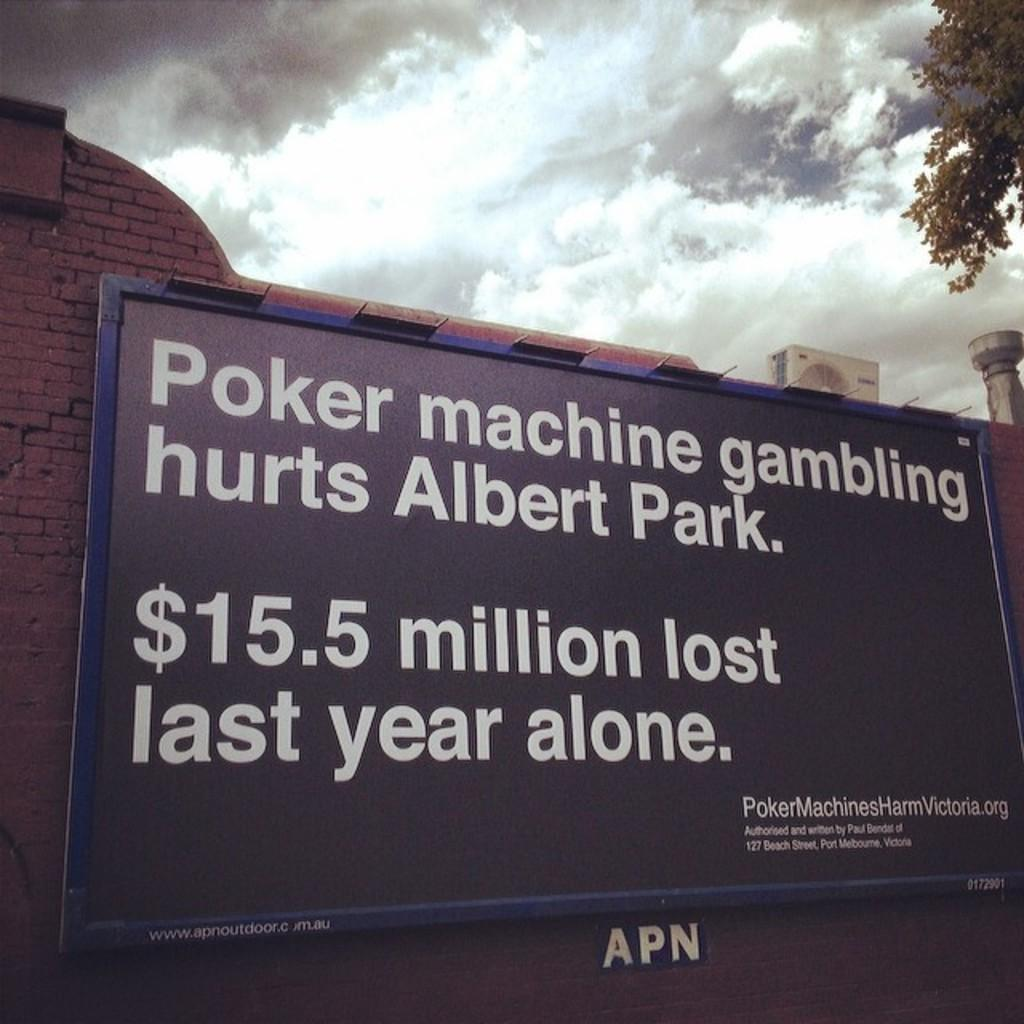What is located in the foreground of the image? There is a board in the foreground of the image. What can be seen on the left side of the image? There is a brick wall on the left side of the image. How many air conditioners are visible at the top right of the image? There are three air conditioners at the top right of the image. What else is present at the top right of the image? There is a pole at the top right of the image. What is visible at the top of the image? The sky is visible at the top of the image. What type of cloud is floating above the brick wall in the image? There is no cloud visible in the image; only a brick wall, a board, air conditioners, a pole, and the sky are present. What rod is holding up the board in the image? There is no rod holding up the board in the image; it is not mentioned in the provided facts. 